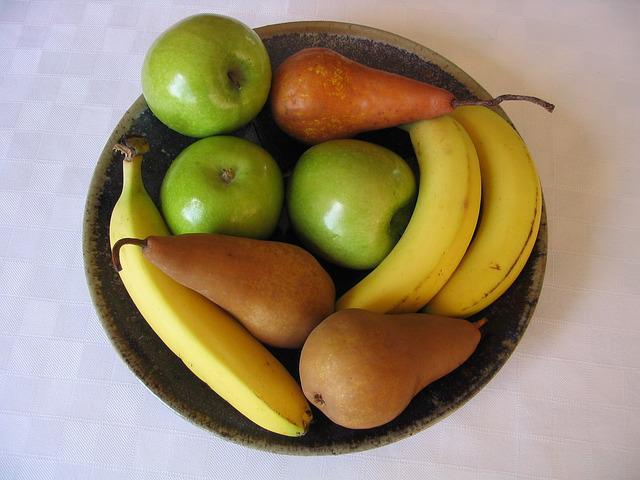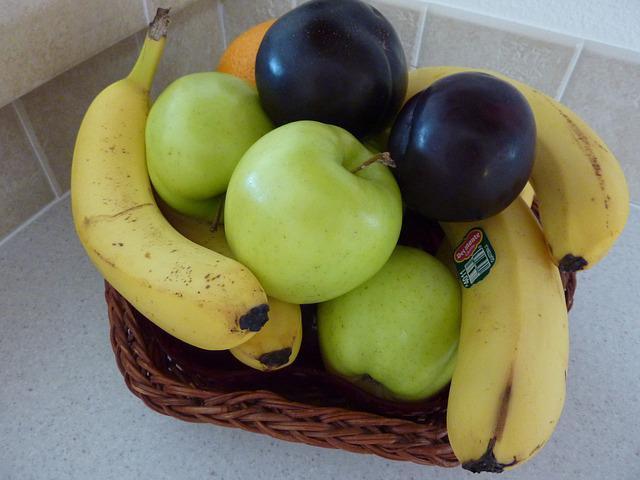The first image is the image on the left, the second image is the image on the right. Assess this claim about the two images: "There are entirely green apples among the fruit in the right image.". Correct or not? Answer yes or no. Yes. The first image is the image on the left, the second image is the image on the right. Given the left and right images, does the statement "An image shows fruit that is not in a container and includes at least one yellow banana and yellow-green pear." hold true? Answer yes or no. No. 